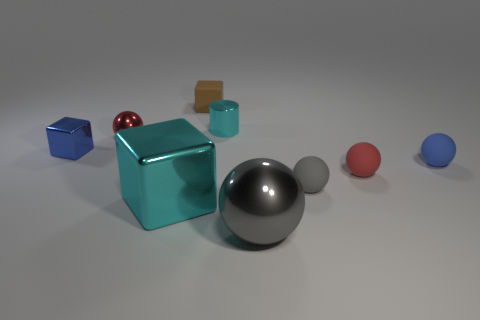Subtract all small cubes. How many cubes are left? 1 Subtract all blue blocks. How many blocks are left? 2 Subtract 3 balls. How many balls are left? 2 Subtract all green blocks. Subtract all gray cylinders. How many blocks are left? 3 Subtract all yellow cylinders. How many green cubes are left? 0 Subtract all tiny blocks. Subtract all big cyan things. How many objects are left? 6 Add 2 small shiny things. How many small shiny things are left? 5 Add 6 big purple rubber objects. How many big purple rubber objects exist? 6 Subtract 0 green balls. How many objects are left? 9 Subtract all balls. How many objects are left? 4 